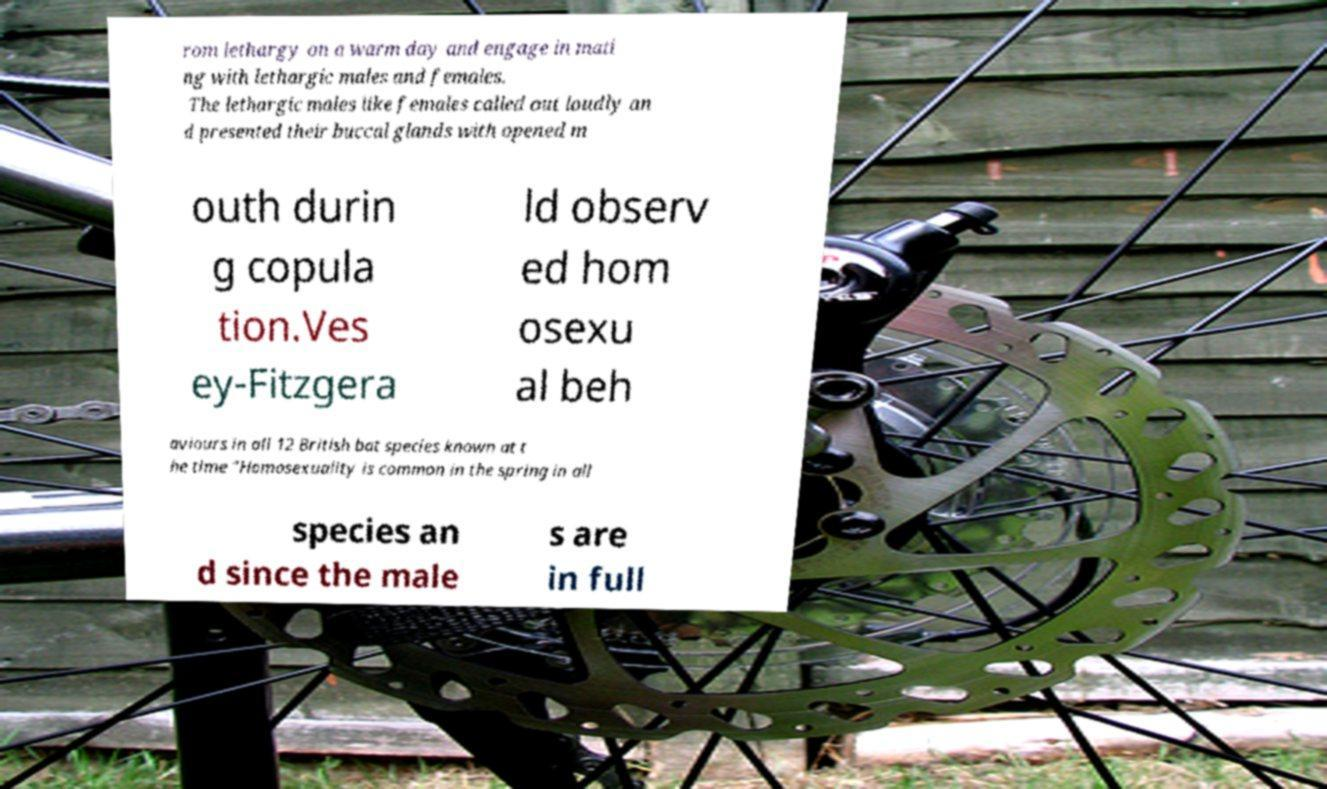Could you assist in decoding the text presented in this image and type it out clearly? rom lethargy on a warm day and engage in mati ng with lethargic males and females. The lethargic males like females called out loudly an d presented their buccal glands with opened m outh durin g copula tion.Ves ey-Fitzgera ld observ ed hom osexu al beh aviours in all 12 British bat species known at t he time “Homosexuality is common in the spring in all species an d since the male s are in full 